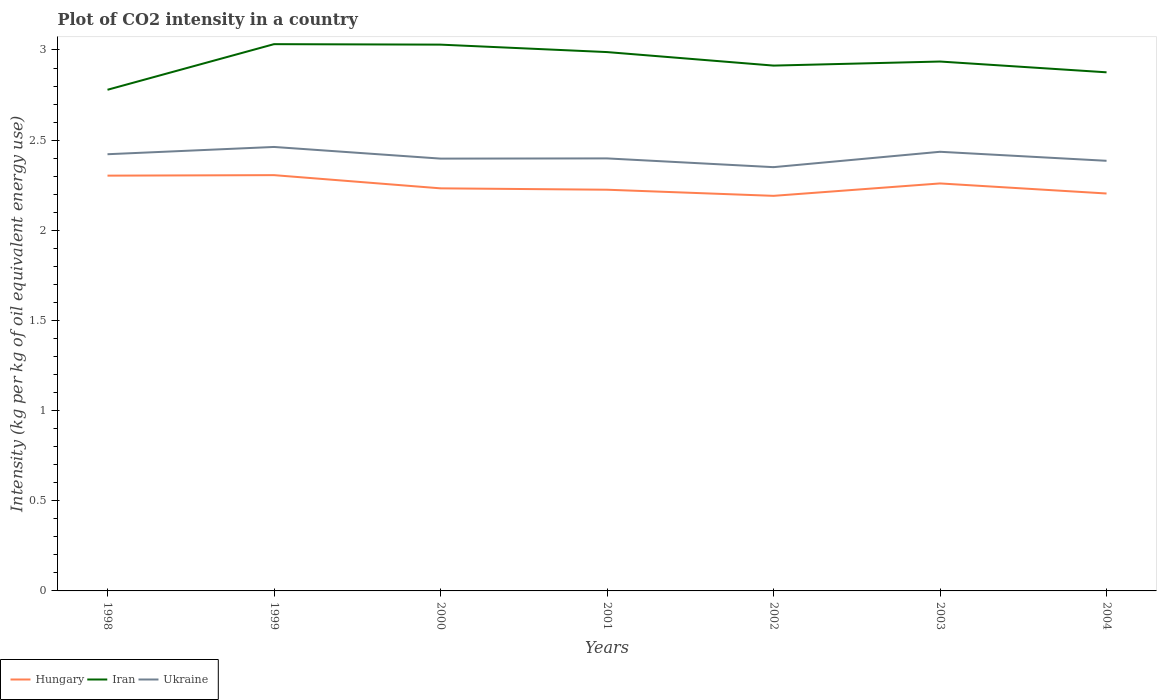How many different coloured lines are there?
Provide a succinct answer. 3. Does the line corresponding to Ukraine intersect with the line corresponding to Iran?
Your answer should be compact. No. Across all years, what is the maximum CO2 intensity in in Ukraine?
Offer a terse response. 2.35. What is the total CO2 intensity in in Ukraine in the graph?
Ensure brevity in your answer.  -0.04. What is the difference between the highest and the second highest CO2 intensity in in Ukraine?
Keep it short and to the point. 0.11. What is the difference between the highest and the lowest CO2 intensity in in Iran?
Give a very brief answer. 3. Is the CO2 intensity in in Iran strictly greater than the CO2 intensity in in Ukraine over the years?
Keep it short and to the point. No. How many lines are there?
Give a very brief answer. 3. What is the difference between two consecutive major ticks on the Y-axis?
Give a very brief answer. 0.5. Does the graph contain grids?
Your answer should be compact. No. Where does the legend appear in the graph?
Keep it short and to the point. Bottom left. What is the title of the graph?
Your answer should be compact. Plot of CO2 intensity in a country. Does "Isle of Man" appear as one of the legend labels in the graph?
Provide a short and direct response. No. What is the label or title of the X-axis?
Your response must be concise. Years. What is the label or title of the Y-axis?
Your response must be concise. Intensity (kg per kg of oil equivalent energy use). What is the Intensity (kg per kg of oil equivalent energy use) in Hungary in 1998?
Make the answer very short. 2.3. What is the Intensity (kg per kg of oil equivalent energy use) in Iran in 1998?
Keep it short and to the point. 2.78. What is the Intensity (kg per kg of oil equivalent energy use) of Ukraine in 1998?
Your answer should be compact. 2.42. What is the Intensity (kg per kg of oil equivalent energy use) of Hungary in 1999?
Provide a succinct answer. 2.31. What is the Intensity (kg per kg of oil equivalent energy use) in Iran in 1999?
Offer a terse response. 3.03. What is the Intensity (kg per kg of oil equivalent energy use) in Ukraine in 1999?
Your response must be concise. 2.46. What is the Intensity (kg per kg of oil equivalent energy use) in Hungary in 2000?
Your answer should be compact. 2.23. What is the Intensity (kg per kg of oil equivalent energy use) in Iran in 2000?
Your answer should be very brief. 3.03. What is the Intensity (kg per kg of oil equivalent energy use) in Ukraine in 2000?
Ensure brevity in your answer.  2.4. What is the Intensity (kg per kg of oil equivalent energy use) in Hungary in 2001?
Offer a terse response. 2.23. What is the Intensity (kg per kg of oil equivalent energy use) of Iran in 2001?
Offer a very short reply. 2.99. What is the Intensity (kg per kg of oil equivalent energy use) of Ukraine in 2001?
Keep it short and to the point. 2.4. What is the Intensity (kg per kg of oil equivalent energy use) of Hungary in 2002?
Offer a very short reply. 2.19. What is the Intensity (kg per kg of oil equivalent energy use) in Iran in 2002?
Offer a terse response. 2.91. What is the Intensity (kg per kg of oil equivalent energy use) in Ukraine in 2002?
Ensure brevity in your answer.  2.35. What is the Intensity (kg per kg of oil equivalent energy use) in Hungary in 2003?
Offer a very short reply. 2.26. What is the Intensity (kg per kg of oil equivalent energy use) in Iran in 2003?
Offer a very short reply. 2.94. What is the Intensity (kg per kg of oil equivalent energy use) of Ukraine in 2003?
Your response must be concise. 2.44. What is the Intensity (kg per kg of oil equivalent energy use) in Hungary in 2004?
Provide a short and direct response. 2.2. What is the Intensity (kg per kg of oil equivalent energy use) of Iran in 2004?
Ensure brevity in your answer.  2.88. What is the Intensity (kg per kg of oil equivalent energy use) in Ukraine in 2004?
Your answer should be compact. 2.39. Across all years, what is the maximum Intensity (kg per kg of oil equivalent energy use) in Hungary?
Your answer should be compact. 2.31. Across all years, what is the maximum Intensity (kg per kg of oil equivalent energy use) of Iran?
Your answer should be very brief. 3.03. Across all years, what is the maximum Intensity (kg per kg of oil equivalent energy use) of Ukraine?
Offer a very short reply. 2.46. Across all years, what is the minimum Intensity (kg per kg of oil equivalent energy use) of Hungary?
Offer a very short reply. 2.19. Across all years, what is the minimum Intensity (kg per kg of oil equivalent energy use) of Iran?
Provide a short and direct response. 2.78. Across all years, what is the minimum Intensity (kg per kg of oil equivalent energy use) of Ukraine?
Give a very brief answer. 2.35. What is the total Intensity (kg per kg of oil equivalent energy use) in Hungary in the graph?
Offer a terse response. 15.72. What is the total Intensity (kg per kg of oil equivalent energy use) in Iran in the graph?
Keep it short and to the point. 20.56. What is the total Intensity (kg per kg of oil equivalent energy use) in Ukraine in the graph?
Provide a short and direct response. 16.85. What is the difference between the Intensity (kg per kg of oil equivalent energy use) in Hungary in 1998 and that in 1999?
Provide a succinct answer. -0. What is the difference between the Intensity (kg per kg of oil equivalent energy use) in Iran in 1998 and that in 1999?
Your answer should be very brief. -0.25. What is the difference between the Intensity (kg per kg of oil equivalent energy use) of Ukraine in 1998 and that in 1999?
Make the answer very short. -0.04. What is the difference between the Intensity (kg per kg of oil equivalent energy use) in Hungary in 1998 and that in 2000?
Ensure brevity in your answer.  0.07. What is the difference between the Intensity (kg per kg of oil equivalent energy use) of Iran in 1998 and that in 2000?
Provide a short and direct response. -0.25. What is the difference between the Intensity (kg per kg of oil equivalent energy use) of Ukraine in 1998 and that in 2000?
Make the answer very short. 0.02. What is the difference between the Intensity (kg per kg of oil equivalent energy use) of Hungary in 1998 and that in 2001?
Provide a short and direct response. 0.08. What is the difference between the Intensity (kg per kg of oil equivalent energy use) in Iran in 1998 and that in 2001?
Ensure brevity in your answer.  -0.21. What is the difference between the Intensity (kg per kg of oil equivalent energy use) in Ukraine in 1998 and that in 2001?
Make the answer very short. 0.02. What is the difference between the Intensity (kg per kg of oil equivalent energy use) of Hungary in 1998 and that in 2002?
Your answer should be very brief. 0.11. What is the difference between the Intensity (kg per kg of oil equivalent energy use) in Iran in 1998 and that in 2002?
Make the answer very short. -0.13. What is the difference between the Intensity (kg per kg of oil equivalent energy use) of Ukraine in 1998 and that in 2002?
Provide a succinct answer. 0.07. What is the difference between the Intensity (kg per kg of oil equivalent energy use) of Hungary in 1998 and that in 2003?
Offer a very short reply. 0.04. What is the difference between the Intensity (kg per kg of oil equivalent energy use) of Iran in 1998 and that in 2003?
Keep it short and to the point. -0.16. What is the difference between the Intensity (kg per kg of oil equivalent energy use) of Ukraine in 1998 and that in 2003?
Provide a succinct answer. -0.01. What is the difference between the Intensity (kg per kg of oil equivalent energy use) in Hungary in 1998 and that in 2004?
Ensure brevity in your answer.  0.1. What is the difference between the Intensity (kg per kg of oil equivalent energy use) of Iran in 1998 and that in 2004?
Provide a succinct answer. -0.1. What is the difference between the Intensity (kg per kg of oil equivalent energy use) in Ukraine in 1998 and that in 2004?
Your response must be concise. 0.04. What is the difference between the Intensity (kg per kg of oil equivalent energy use) in Hungary in 1999 and that in 2000?
Offer a terse response. 0.07. What is the difference between the Intensity (kg per kg of oil equivalent energy use) of Iran in 1999 and that in 2000?
Your response must be concise. 0. What is the difference between the Intensity (kg per kg of oil equivalent energy use) in Ukraine in 1999 and that in 2000?
Your answer should be compact. 0.06. What is the difference between the Intensity (kg per kg of oil equivalent energy use) of Hungary in 1999 and that in 2001?
Offer a terse response. 0.08. What is the difference between the Intensity (kg per kg of oil equivalent energy use) of Iran in 1999 and that in 2001?
Your answer should be compact. 0.04. What is the difference between the Intensity (kg per kg of oil equivalent energy use) in Ukraine in 1999 and that in 2001?
Provide a succinct answer. 0.06. What is the difference between the Intensity (kg per kg of oil equivalent energy use) in Hungary in 1999 and that in 2002?
Make the answer very short. 0.11. What is the difference between the Intensity (kg per kg of oil equivalent energy use) in Iran in 1999 and that in 2002?
Offer a very short reply. 0.12. What is the difference between the Intensity (kg per kg of oil equivalent energy use) in Ukraine in 1999 and that in 2002?
Make the answer very short. 0.11. What is the difference between the Intensity (kg per kg of oil equivalent energy use) in Hungary in 1999 and that in 2003?
Keep it short and to the point. 0.05. What is the difference between the Intensity (kg per kg of oil equivalent energy use) of Iran in 1999 and that in 2003?
Provide a succinct answer. 0.1. What is the difference between the Intensity (kg per kg of oil equivalent energy use) of Ukraine in 1999 and that in 2003?
Offer a very short reply. 0.03. What is the difference between the Intensity (kg per kg of oil equivalent energy use) of Hungary in 1999 and that in 2004?
Keep it short and to the point. 0.1. What is the difference between the Intensity (kg per kg of oil equivalent energy use) in Iran in 1999 and that in 2004?
Make the answer very short. 0.16. What is the difference between the Intensity (kg per kg of oil equivalent energy use) in Ukraine in 1999 and that in 2004?
Make the answer very short. 0.08. What is the difference between the Intensity (kg per kg of oil equivalent energy use) in Hungary in 2000 and that in 2001?
Provide a short and direct response. 0.01. What is the difference between the Intensity (kg per kg of oil equivalent energy use) of Iran in 2000 and that in 2001?
Offer a very short reply. 0.04. What is the difference between the Intensity (kg per kg of oil equivalent energy use) in Ukraine in 2000 and that in 2001?
Your response must be concise. -0. What is the difference between the Intensity (kg per kg of oil equivalent energy use) in Hungary in 2000 and that in 2002?
Provide a succinct answer. 0.04. What is the difference between the Intensity (kg per kg of oil equivalent energy use) in Iran in 2000 and that in 2002?
Give a very brief answer. 0.12. What is the difference between the Intensity (kg per kg of oil equivalent energy use) in Ukraine in 2000 and that in 2002?
Give a very brief answer. 0.05. What is the difference between the Intensity (kg per kg of oil equivalent energy use) in Hungary in 2000 and that in 2003?
Give a very brief answer. -0.03. What is the difference between the Intensity (kg per kg of oil equivalent energy use) in Iran in 2000 and that in 2003?
Your answer should be very brief. 0.09. What is the difference between the Intensity (kg per kg of oil equivalent energy use) in Ukraine in 2000 and that in 2003?
Keep it short and to the point. -0.04. What is the difference between the Intensity (kg per kg of oil equivalent energy use) of Hungary in 2000 and that in 2004?
Give a very brief answer. 0.03. What is the difference between the Intensity (kg per kg of oil equivalent energy use) of Iran in 2000 and that in 2004?
Make the answer very short. 0.15. What is the difference between the Intensity (kg per kg of oil equivalent energy use) of Ukraine in 2000 and that in 2004?
Provide a short and direct response. 0.01. What is the difference between the Intensity (kg per kg of oil equivalent energy use) of Hungary in 2001 and that in 2002?
Provide a short and direct response. 0.03. What is the difference between the Intensity (kg per kg of oil equivalent energy use) in Iran in 2001 and that in 2002?
Give a very brief answer. 0.07. What is the difference between the Intensity (kg per kg of oil equivalent energy use) in Ukraine in 2001 and that in 2002?
Ensure brevity in your answer.  0.05. What is the difference between the Intensity (kg per kg of oil equivalent energy use) in Hungary in 2001 and that in 2003?
Offer a very short reply. -0.03. What is the difference between the Intensity (kg per kg of oil equivalent energy use) of Iran in 2001 and that in 2003?
Offer a very short reply. 0.05. What is the difference between the Intensity (kg per kg of oil equivalent energy use) of Ukraine in 2001 and that in 2003?
Provide a short and direct response. -0.04. What is the difference between the Intensity (kg per kg of oil equivalent energy use) in Hungary in 2001 and that in 2004?
Your response must be concise. 0.02. What is the difference between the Intensity (kg per kg of oil equivalent energy use) in Iran in 2001 and that in 2004?
Provide a succinct answer. 0.11. What is the difference between the Intensity (kg per kg of oil equivalent energy use) in Ukraine in 2001 and that in 2004?
Make the answer very short. 0.01. What is the difference between the Intensity (kg per kg of oil equivalent energy use) of Hungary in 2002 and that in 2003?
Provide a short and direct response. -0.07. What is the difference between the Intensity (kg per kg of oil equivalent energy use) in Iran in 2002 and that in 2003?
Offer a terse response. -0.02. What is the difference between the Intensity (kg per kg of oil equivalent energy use) of Ukraine in 2002 and that in 2003?
Provide a succinct answer. -0.09. What is the difference between the Intensity (kg per kg of oil equivalent energy use) in Hungary in 2002 and that in 2004?
Give a very brief answer. -0.01. What is the difference between the Intensity (kg per kg of oil equivalent energy use) of Iran in 2002 and that in 2004?
Keep it short and to the point. 0.04. What is the difference between the Intensity (kg per kg of oil equivalent energy use) in Ukraine in 2002 and that in 2004?
Provide a short and direct response. -0.04. What is the difference between the Intensity (kg per kg of oil equivalent energy use) in Hungary in 2003 and that in 2004?
Give a very brief answer. 0.06. What is the difference between the Intensity (kg per kg of oil equivalent energy use) of Iran in 2003 and that in 2004?
Ensure brevity in your answer.  0.06. What is the difference between the Intensity (kg per kg of oil equivalent energy use) in Ukraine in 2003 and that in 2004?
Provide a short and direct response. 0.05. What is the difference between the Intensity (kg per kg of oil equivalent energy use) in Hungary in 1998 and the Intensity (kg per kg of oil equivalent energy use) in Iran in 1999?
Offer a very short reply. -0.73. What is the difference between the Intensity (kg per kg of oil equivalent energy use) of Hungary in 1998 and the Intensity (kg per kg of oil equivalent energy use) of Ukraine in 1999?
Provide a succinct answer. -0.16. What is the difference between the Intensity (kg per kg of oil equivalent energy use) of Iran in 1998 and the Intensity (kg per kg of oil equivalent energy use) of Ukraine in 1999?
Your answer should be compact. 0.32. What is the difference between the Intensity (kg per kg of oil equivalent energy use) in Hungary in 1998 and the Intensity (kg per kg of oil equivalent energy use) in Iran in 2000?
Give a very brief answer. -0.73. What is the difference between the Intensity (kg per kg of oil equivalent energy use) of Hungary in 1998 and the Intensity (kg per kg of oil equivalent energy use) of Ukraine in 2000?
Your response must be concise. -0.09. What is the difference between the Intensity (kg per kg of oil equivalent energy use) of Iran in 1998 and the Intensity (kg per kg of oil equivalent energy use) of Ukraine in 2000?
Give a very brief answer. 0.38. What is the difference between the Intensity (kg per kg of oil equivalent energy use) of Hungary in 1998 and the Intensity (kg per kg of oil equivalent energy use) of Iran in 2001?
Make the answer very short. -0.69. What is the difference between the Intensity (kg per kg of oil equivalent energy use) in Hungary in 1998 and the Intensity (kg per kg of oil equivalent energy use) in Ukraine in 2001?
Provide a succinct answer. -0.1. What is the difference between the Intensity (kg per kg of oil equivalent energy use) in Iran in 1998 and the Intensity (kg per kg of oil equivalent energy use) in Ukraine in 2001?
Make the answer very short. 0.38. What is the difference between the Intensity (kg per kg of oil equivalent energy use) in Hungary in 1998 and the Intensity (kg per kg of oil equivalent energy use) in Iran in 2002?
Your answer should be compact. -0.61. What is the difference between the Intensity (kg per kg of oil equivalent energy use) of Hungary in 1998 and the Intensity (kg per kg of oil equivalent energy use) of Ukraine in 2002?
Provide a succinct answer. -0.05. What is the difference between the Intensity (kg per kg of oil equivalent energy use) in Iran in 1998 and the Intensity (kg per kg of oil equivalent energy use) in Ukraine in 2002?
Keep it short and to the point. 0.43. What is the difference between the Intensity (kg per kg of oil equivalent energy use) of Hungary in 1998 and the Intensity (kg per kg of oil equivalent energy use) of Iran in 2003?
Offer a terse response. -0.63. What is the difference between the Intensity (kg per kg of oil equivalent energy use) in Hungary in 1998 and the Intensity (kg per kg of oil equivalent energy use) in Ukraine in 2003?
Your answer should be very brief. -0.13. What is the difference between the Intensity (kg per kg of oil equivalent energy use) of Iran in 1998 and the Intensity (kg per kg of oil equivalent energy use) of Ukraine in 2003?
Provide a short and direct response. 0.34. What is the difference between the Intensity (kg per kg of oil equivalent energy use) in Hungary in 1998 and the Intensity (kg per kg of oil equivalent energy use) in Iran in 2004?
Offer a very short reply. -0.57. What is the difference between the Intensity (kg per kg of oil equivalent energy use) in Hungary in 1998 and the Intensity (kg per kg of oil equivalent energy use) in Ukraine in 2004?
Offer a terse response. -0.08. What is the difference between the Intensity (kg per kg of oil equivalent energy use) of Iran in 1998 and the Intensity (kg per kg of oil equivalent energy use) of Ukraine in 2004?
Ensure brevity in your answer.  0.39. What is the difference between the Intensity (kg per kg of oil equivalent energy use) in Hungary in 1999 and the Intensity (kg per kg of oil equivalent energy use) in Iran in 2000?
Make the answer very short. -0.72. What is the difference between the Intensity (kg per kg of oil equivalent energy use) in Hungary in 1999 and the Intensity (kg per kg of oil equivalent energy use) in Ukraine in 2000?
Offer a terse response. -0.09. What is the difference between the Intensity (kg per kg of oil equivalent energy use) of Iran in 1999 and the Intensity (kg per kg of oil equivalent energy use) of Ukraine in 2000?
Provide a succinct answer. 0.63. What is the difference between the Intensity (kg per kg of oil equivalent energy use) of Hungary in 1999 and the Intensity (kg per kg of oil equivalent energy use) of Iran in 2001?
Provide a succinct answer. -0.68. What is the difference between the Intensity (kg per kg of oil equivalent energy use) of Hungary in 1999 and the Intensity (kg per kg of oil equivalent energy use) of Ukraine in 2001?
Keep it short and to the point. -0.09. What is the difference between the Intensity (kg per kg of oil equivalent energy use) in Iran in 1999 and the Intensity (kg per kg of oil equivalent energy use) in Ukraine in 2001?
Your answer should be compact. 0.63. What is the difference between the Intensity (kg per kg of oil equivalent energy use) in Hungary in 1999 and the Intensity (kg per kg of oil equivalent energy use) in Iran in 2002?
Offer a very short reply. -0.61. What is the difference between the Intensity (kg per kg of oil equivalent energy use) of Hungary in 1999 and the Intensity (kg per kg of oil equivalent energy use) of Ukraine in 2002?
Make the answer very short. -0.04. What is the difference between the Intensity (kg per kg of oil equivalent energy use) in Iran in 1999 and the Intensity (kg per kg of oil equivalent energy use) in Ukraine in 2002?
Ensure brevity in your answer.  0.68. What is the difference between the Intensity (kg per kg of oil equivalent energy use) in Hungary in 1999 and the Intensity (kg per kg of oil equivalent energy use) in Iran in 2003?
Your answer should be compact. -0.63. What is the difference between the Intensity (kg per kg of oil equivalent energy use) in Hungary in 1999 and the Intensity (kg per kg of oil equivalent energy use) in Ukraine in 2003?
Give a very brief answer. -0.13. What is the difference between the Intensity (kg per kg of oil equivalent energy use) of Iran in 1999 and the Intensity (kg per kg of oil equivalent energy use) of Ukraine in 2003?
Offer a very short reply. 0.6. What is the difference between the Intensity (kg per kg of oil equivalent energy use) of Hungary in 1999 and the Intensity (kg per kg of oil equivalent energy use) of Iran in 2004?
Provide a succinct answer. -0.57. What is the difference between the Intensity (kg per kg of oil equivalent energy use) in Hungary in 1999 and the Intensity (kg per kg of oil equivalent energy use) in Ukraine in 2004?
Provide a succinct answer. -0.08. What is the difference between the Intensity (kg per kg of oil equivalent energy use) in Iran in 1999 and the Intensity (kg per kg of oil equivalent energy use) in Ukraine in 2004?
Offer a very short reply. 0.65. What is the difference between the Intensity (kg per kg of oil equivalent energy use) of Hungary in 2000 and the Intensity (kg per kg of oil equivalent energy use) of Iran in 2001?
Provide a succinct answer. -0.76. What is the difference between the Intensity (kg per kg of oil equivalent energy use) of Hungary in 2000 and the Intensity (kg per kg of oil equivalent energy use) of Ukraine in 2001?
Offer a terse response. -0.17. What is the difference between the Intensity (kg per kg of oil equivalent energy use) in Iran in 2000 and the Intensity (kg per kg of oil equivalent energy use) in Ukraine in 2001?
Provide a succinct answer. 0.63. What is the difference between the Intensity (kg per kg of oil equivalent energy use) of Hungary in 2000 and the Intensity (kg per kg of oil equivalent energy use) of Iran in 2002?
Make the answer very short. -0.68. What is the difference between the Intensity (kg per kg of oil equivalent energy use) of Hungary in 2000 and the Intensity (kg per kg of oil equivalent energy use) of Ukraine in 2002?
Provide a succinct answer. -0.12. What is the difference between the Intensity (kg per kg of oil equivalent energy use) of Iran in 2000 and the Intensity (kg per kg of oil equivalent energy use) of Ukraine in 2002?
Ensure brevity in your answer.  0.68. What is the difference between the Intensity (kg per kg of oil equivalent energy use) in Hungary in 2000 and the Intensity (kg per kg of oil equivalent energy use) in Iran in 2003?
Offer a very short reply. -0.7. What is the difference between the Intensity (kg per kg of oil equivalent energy use) in Hungary in 2000 and the Intensity (kg per kg of oil equivalent energy use) in Ukraine in 2003?
Ensure brevity in your answer.  -0.2. What is the difference between the Intensity (kg per kg of oil equivalent energy use) of Iran in 2000 and the Intensity (kg per kg of oil equivalent energy use) of Ukraine in 2003?
Provide a short and direct response. 0.59. What is the difference between the Intensity (kg per kg of oil equivalent energy use) in Hungary in 2000 and the Intensity (kg per kg of oil equivalent energy use) in Iran in 2004?
Your answer should be compact. -0.64. What is the difference between the Intensity (kg per kg of oil equivalent energy use) of Hungary in 2000 and the Intensity (kg per kg of oil equivalent energy use) of Ukraine in 2004?
Make the answer very short. -0.15. What is the difference between the Intensity (kg per kg of oil equivalent energy use) in Iran in 2000 and the Intensity (kg per kg of oil equivalent energy use) in Ukraine in 2004?
Offer a terse response. 0.64. What is the difference between the Intensity (kg per kg of oil equivalent energy use) of Hungary in 2001 and the Intensity (kg per kg of oil equivalent energy use) of Iran in 2002?
Give a very brief answer. -0.69. What is the difference between the Intensity (kg per kg of oil equivalent energy use) in Hungary in 2001 and the Intensity (kg per kg of oil equivalent energy use) in Ukraine in 2002?
Offer a terse response. -0.13. What is the difference between the Intensity (kg per kg of oil equivalent energy use) of Iran in 2001 and the Intensity (kg per kg of oil equivalent energy use) of Ukraine in 2002?
Your response must be concise. 0.64. What is the difference between the Intensity (kg per kg of oil equivalent energy use) of Hungary in 2001 and the Intensity (kg per kg of oil equivalent energy use) of Iran in 2003?
Your response must be concise. -0.71. What is the difference between the Intensity (kg per kg of oil equivalent energy use) in Hungary in 2001 and the Intensity (kg per kg of oil equivalent energy use) in Ukraine in 2003?
Ensure brevity in your answer.  -0.21. What is the difference between the Intensity (kg per kg of oil equivalent energy use) in Iran in 2001 and the Intensity (kg per kg of oil equivalent energy use) in Ukraine in 2003?
Offer a terse response. 0.55. What is the difference between the Intensity (kg per kg of oil equivalent energy use) in Hungary in 2001 and the Intensity (kg per kg of oil equivalent energy use) in Iran in 2004?
Give a very brief answer. -0.65. What is the difference between the Intensity (kg per kg of oil equivalent energy use) of Hungary in 2001 and the Intensity (kg per kg of oil equivalent energy use) of Ukraine in 2004?
Offer a very short reply. -0.16. What is the difference between the Intensity (kg per kg of oil equivalent energy use) of Iran in 2001 and the Intensity (kg per kg of oil equivalent energy use) of Ukraine in 2004?
Your answer should be compact. 0.6. What is the difference between the Intensity (kg per kg of oil equivalent energy use) in Hungary in 2002 and the Intensity (kg per kg of oil equivalent energy use) in Iran in 2003?
Provide a short and direct response. -0.74. What is the difference between the Intensity (kg per kg of oil equivalent energy use) of Hungary in 2002 and the Intensity (kg per kg of oil equivalent energy use) of Ukraine in 2003?
Offer a very short reply. -0.24. What is the difference between the Intensity (kg per kg of oil equivalent energy use) in Iran in 2002 and the Intensity (kg per kg of oil equivalent energy use) in Ukraine in 2003?
Offer a terse response. 0.48. What is the difference between the Intensity (kg per kg of oil equivalent energy use) of Hungary in 2002 and the Intensity (kg per kg of oil equivalent energy use) of Iran in 2004?
Your answer should be compact. -0.69. What is the difference between the Intensity (kg per kg of oil equivalent energy use) of Hungary in 2002 and the Intensity (kg per kg of oil equivalent energy use) of Ukraine in 2004?
Provide a succinct answer. -0.19. What is the difference between the Intensity (kg per kg of oil equivalent energy use) in Iran in 2002 and the Intensity (kg per kg of oil equivalent energy use) in Ukraine in 2004?
Offer a very short reply. 0.53. What is the difference between the Intensity (kg per kg of oil equivalent energy use) in Hungary in 2003 and the Intensity (kg per kg of oil equivalent energy use) in Iran in 2004?
Your response must be concise. -0.62. What is the difference between the Intensity (kg per kg of oil equivalent energy use) in Hungary in 2003 and the Intensity (kg per kg of oil equivalent energy use) in Ukraine in 2004?
Your response must be concise. -0.13. What is the difference between the Intensity (kg per kg of oil equivalent energy use) of Iran in 2003 and the Intensity (kg per kg of oil equivalent energy use) of Ukraine in 2004?
Offer a very short reply. 0.55. What is the average Intensity (kg per kg of oil equivalent energy use) of Hungary per year?
Give a very brief answer. 2.25. What is the average Intensity (kg per kg of oil equivalent energy use) in Iran per year?
Your response must be concise. 2.94. What is the average Intensity (kg per kg of oil equivalent energy use) of Ukraine per year?
Provide a succinct answer. 2.41. In the year 1998, what is the difference between the Intensity (kg per kg of oil equivalent energy use) of Hungary and Intensity (kg per kg of oil equivalent energy use) of Iran?
Your answer should be very brief. -0.48. In the year 1998, what is the difference between the Intensity (kg per kg of oil equivalent energy use) in Hungary and Intensity (kg per kg of oil equivalent energy use) in Ukraine?
Offer a terse response. -0.12. In the year 1998, what is the difference between the Intensity (kg per kg of oil equivalent energy use) of Iran and Intensity (kg per kg of oil equivalent energy use) of Ukraine?
Provide a short and direct response. 0.36. In the year 1999, what is the difference between the Intensity (kg per kg of oil equivalent energy use) of Hungary and Intensity (kg per kg of oil equivalent energy use) of Iran?
Your answer should be compact. -0.73. In the year 1999, what is the difference between the Intensity (kg per kg of oil equivalent energy use) in Hungary and Intensity (kg per kg of oil equivalent energy use) in Ukraine?
Give a very brief answer. -0.16. In the year 1999, what is the difference between the Intensity (kg per kg of oil equivalent energy use) in Iran and Intensity (kg per kg of oil equivalent energy use) in Ukraine?
Offer a terse response. 0.57. In the year 2000, what is the difference between the Intensity (kg per kg of oil equivalent energy use) in Hungary and Intensity (kg per kg of oil equivalent energy use) in Iran?
Offer a very short reply. -0.8. In the year 2000, what is the difference between the Intensity (kg per kg of oil equivalent energy use) of Hungary and Intensity (kg per kg of oil equivalent energy use) of Ukraine?
Ensure brevity in your answer.  -0.16. In the year 2000, what is the difference between the Intensity (kg per kg of oil equivalent energy use) of Iran and Intensity (kg per kg of oil equivalent energy use) of Ukraine?
Provide a short and direct response. 0.63. In the year 2001, what is the difference between the Intensity (kg per kg of oil equivalent energy use) in Hungary and Intensity (kg per kg of oil equivalent energy use) in Iran?
Make the answer very short. -0.76. In the year 2001, what is the difference between the Intensity (kg per kg of oil equivalent energy use) of Hungary and Intensity (kg per kg of oil equivalent energy use) of Ukraine?
Your answer should be very brief. -0.17. In the year 2001, what is the difference between the Intensity (kg per kg of oil equivalent energy use) in Iran and Intensity (kg per kg of oil equivalent energy use) in Ukraine?
Your answer should be very brief. 0.59. In the year 2002, what is the difference between the Intensity (kg per kg of oil equivalent energy use) in Hungary and Intensity (kg per kg of oil equivalent energy use) in Iran?
Provide a short and direct response. -0.72. In the year 2002, what is the difference between the Intensity (kg per kg of oil equivalent energy use) in Hungary and Intensity (kg per kg of oil equivalent energy use) in Ukraine?
Your answer should be compact. -0.16. In the year 2002, what is the difference between the Intensity (kg per kg of oil equivalent energy use) in Iran and Intensity (kg per kg of oil equivalent energy use) in Ukraine?
Provide a succinct answer. 0.56. In the year 2003, what is the difference between the Intensity (kg per kg of oil equivalent energy use) of Hungary and Intensity (kg per kg of oil equivalent energy use) of Iran?
Keep it short and to the point. -0.68. In the year 2003, what is the difference between the Intensity (kg per kg of oil equivalent energy use) in Hungary and Intensity (kg per kg of oil equivalent energy use) in Ukraine?
Provide a short and direct response. -0.18. In the year 2003, what is the difference between the Intensity (kg per kg of oil equivalent energy use) of Iran and Intensity (kg per kg of oil equivalent energy use) of Ukraine?
Provide a short and direct response. 0.5. In the year 2004, what is the difference between the Intensity (kg per kg of oil equivalent energy use) in Hungary and Intensity (kg per kg of oil equivalent energy use) in Iran?
Your answer should be very brief. -0.67. In the year 2004, what is the difference between the Intensity (kg per kg of oil equivalent energy use) of Hungary and Intensity (kg per kg of oil equivalent energy use) of Ukraine?
Your response must be concise. -0.18. In the year 2004, what is the difference between the Intensity (kg per kg of oil equivalent energy use) of Iran and Intensity (kg per kg of oil equivalent energy use) of Ukraine?
Provide a succinct answer. 0.49. What is the ratio of the Intensity (kg per kg of oil equivalent energy use) in Hungary in 1998 to that in 1999?
Offer a very short reply. 1. What is the ratio of the Intensity (kg per kg of oil equivalent energy use) in Iran in 1998 to that in 1999?
Your answer should be very brief. 0.92. What is the ratio of the Intensity (kg per kg of oil equivalent energy use) in Ukraine in 1998 to that in 1999?
Keep it short and to the point. 0.98. What is the ratio of the Intensity (kg per kg of oil equivalent energy use) in Hungary in 1998 to that in 2000?
Offer a terse response. 1.03. What is the ratio of the Intensity (kg per kg of oil equivalent energy use) of Iran in 1998 to that in 2000?
Give a very brief answer. 0.92. What is the ratio of the Intensity (kg per kg of oil equivalent energy use) in Ukraine in 1998 to that in 2000?
Your answer should be very brief. 1.01. What is the ratio of the Intensity (kg per kg of oil equivalent energy use) in Hungary in 1998 to that in 2001?
Ensure brevity in your answer.  1.04. What is the ratio of the Intensity (kg per kg of oil equivalent energy use) of Iran in 1998 to that in 2001?
Your answer should be very brief. 0.93. What is the ratio of the Intensity (kg per kg of oil equivalent energy use) of Ukraine in 1998 to that in 2001?
Offer a very short reply. 1.01. What is the ratio of the Intensity (kg per kg of oil equivalent energy use) of Hungary in 1998 to that in 2002?
Keep it short and to the point. 1.05. What is the ratio of the Intensity (kg per kg of oil equivalent energy use) of Iran in 1998 to that in 2002?
Ensure brevity in your answer.  0.95. What is the ratio of the Intensity (kg per kg of oil equivalent energy use) in Ukraine in 1998 to that in 2002?
Provide a short and direct response. 1.03. What is the ratio of the Intensity (kg per kg of oil equivalent energy use) of Hungary in 1998 to that in 2003?
Give a very brief answer. 1.02. What is the ratio of the Intensity (kg per kg of oil equivalent energy use) in Iran in 1998 to that in 2003?
Provide a short and direct response. 0.95. What is the ratio of the Intensity (kg per kg of oil equivalent energy use) in Ukraine in 1998 to that in 2003?
Give a very brief answer. 0.99. What is the ratio of the Intensity (kg per kg of oil equivalent energy use) of Hungary in 1998 to that in 2004?
Your answer should be very brief. 1.04. What is the ratio of the Intensity (kg per kg of oil equivalent energy use) in Iran in 1998 to that in 2004?
Provide a short and direct response. 0.97. What is the ratio of the Intensity (kg per kg of oil equivalent energy use) in Ukraine in 1998 to that in 2004?
Provide a succinct answer. 1.02. What is the ratio of the Intensity (kg per kg of oil equivalent energy use) of Hungary in 1999 to that in 2000?
Your answer should be very brief. 1.03. What is the ratio of the Intensity (kg per kg of oil equivalent energy use) of Ukraine in 1999 to that in 2000?
Offer a very short reply. 1.03. What is the ratio of the Intensity (kg per kg of oil equivalent energy use) of Hungary in 1999 to that in 2001?
Keep it short and to the point. 1.04. What is the ratio of the Intensity (kg per kg of oil equivalent energy use) of Iran in 1999 to that in 2001?
Give a very brief answer. 1.01. What is the ratio of the Intensity (kg per kg of oil equivalent energy use) of Ukraine in 1999 to that in 2001?
Give a very brief answer. 1.03. What is the ratio of the Intensity (kg per kg of oil equivalent energy use) in Hungary in 1999 to that in 2002?
Offer a very short reply. 1.05. What is the ratio of the Intensity (kg per kg of oil equivalent energy use) of Iran in 1999 to that in 2002?
Ensure brevity in your answer.  1.04. What is the ratio of the Intensity (kg per kg of oil equivalent energy use) in Ukraine in 1999 to that in 2002?
Make the answer very short. 1.05. What is the ratio of the Intensity (kg per kg of oil equivalent energy use) of Hungary in 1999 to that in 2003?
Your answer should be compact. 1.02. What is the ratio of the Intensity (kg per kg of oil equivalent energy use) of Iran in 1999 to that in 2003?
Offer a very short reply. 1.03. What is the ratio of the Intensity (kg per kg of oil equivalent energy use) in Hungary in 1999 to that in 2004?
Provide a succinct answer. 1.05. What is the ratio of the Intensity (kg per kg of oil equivalent energy use) of Iran in 1999 to that in 2004?
Ensure brevity in your answer.  1.05. What is the ratio of the Intensity (kg per kg of oil equivalent energy use) of Ukraine in 1999 to that in 2004?
Provide a short and direct response. 1.03. What is the ratio of the Intensity (kg per kg of oil equivalent energy use) in Hungary in 2000 to that in 2001?
Your answer should be compact. 1. What is the ratio of the Intensity (kg per kg of oil equivalent energy use) of Iran in 2000 to that in 2001?
Ensure brevity in your answer.  1.01. What is the ratio of the Intensity (kg per kg of oil equivalent energy use) in Ukraine in 2000 to that in 2001?
Ensure brevity in your answer.  1. What is the ratio of the Intensity (kg per kg of oil equivalent energy use) in Hungary in 2000 to that in 2002?
Make the answer very short. 1.02. What is the ratio of the Intensity (kg per kg of oil equivalent energy use) of Iran in 2000 to that in 2002?
Give a very brief answer. 1.04. What is the ratio of the Intensity (kg per kg of oil equivalent energy use) of Ukraine in 2000 to that in 2002?
Ensure brevity in your answer.  1.02. What is the ratio of the Intensity (kg per kg of oil equivalent energy use) in Iran in 2000 to that in 2003?
Your answer should be compact. 1.03. What is the ratio of the Intensity (kg per kg of oil equivalent energy use) of Ukraine in 2000 to that in 2003?
Offer a terse response. 0.98. What is the ratio of the Intensity (kg per kg of oil equivalent energy use) of Iran in 2000 to that in 2004?
Provide a succinct answer. 1.05. What is the ratio of the Intensity (kg per kg of oil equivalent energy use) of Hungary in 2001 to that in 2002?
Your answer should be very brief. 1.02. What is the ratio of the Intensity (kg per kg of oil equivalent energy use) in Iran in 2001 to that in 2002?
Make the answer very short. 1.03. What is the ratio of the Intensity (kg per kg of oil equivalent energy use) of Ukraine in 2001 to that in 2002?
Your answer should be compact. 1.02. What is the ratio of the Intensity (kg per kg of oil equivalent energy use) of Hungary in 2001 to that in 2003?
Keep it short and to the point. 0.98. What is the ratio of the Intensity (kg per kg of oil equivalent energy use) of Iran in 2001 to that in 2003?
Provide a short and direct response. 1.02. What is the ratio of the Intensity (kg per kg of oil equivalent energy use) of Ukraine in 2001 to that in 2003?
Keep it short and to the point. 0.98. What is the ratio of the Intensity (kg per kg of oil equivalent energy use) of Hungary in 2001 to that in 2004?
Provide a succinct answer. 1.01. What is the ratio of the Intensity (kg per kg of oil equivalent energy use) of Iran in 2001 to that in 2004?
Ensure brevity in your answer.  1.04. What is the ratio of the Intensity (kg per kg of oil equivalent energy use) of Ukraine in 2001 to that in 2004?
Give a very brief answer. 1.01. What is the ratio of the Intensity (kg per kg of oil equivalent energy use) of Hungary in 2002 to that in 2003?
Make the answer very short. 0.97. What is the ratio of the Intensity (kg per kg of oil equivalent energy use) in Ukraine in 2002 to that in 2003?
Offer a terse response. 0.96. What is the ratio of the Intensity (kg per kg of oil equivalent energy use) in Ukraine in 2002 to that in 2004?
Your response must be concise. 0.99. What is the ratio of the Intensity (kg per kg of oil equivalent energy use) of Hungary in 2003 to that in 2004?
Give a very brief answer. 1.03. What is the ratio of the Intensity (kg per kg of oil equivalent energy use) in Iran in 2003 to that in 2004?
Your answer should be compact. 1.02. What is the ratio of the Intensity (kg per kg of oil equivalent energy use) in Ukraine in 2003 to that in 2004?
Give a very brief answer. 1.02. What is the difference between the highest and the second highest Intensity (kg per kg of oil equivalent energy use) of Hungary?
Provide a short and direct response. 0. What is the difference between the highest and the second highest Intensity (kg per kg of oil equivalent energy use) of Iran?
Provide a succinct answer. 0. What is the difference between the highest and the second highest Intensity (kg per kg of oil equivalent energy use) in Ukraine?
Your answer should be very brief. 0.03. What is the difference between the highest and the lowest Intensity (kg per kg of oil equivalent energy use) in Hungary?
Offer a terse response. 0.11. What is the difference between the highest and the lowest Intensity (kg per kg of oil equivalent energy use) of Iran?
Your answer should be very brief. 0.25. What is the difference between the highest and the lowest Intensity (kg per kg of oil equivalent energy use) in Ukraine?
Ensure brevity in your answer.  0.11. 